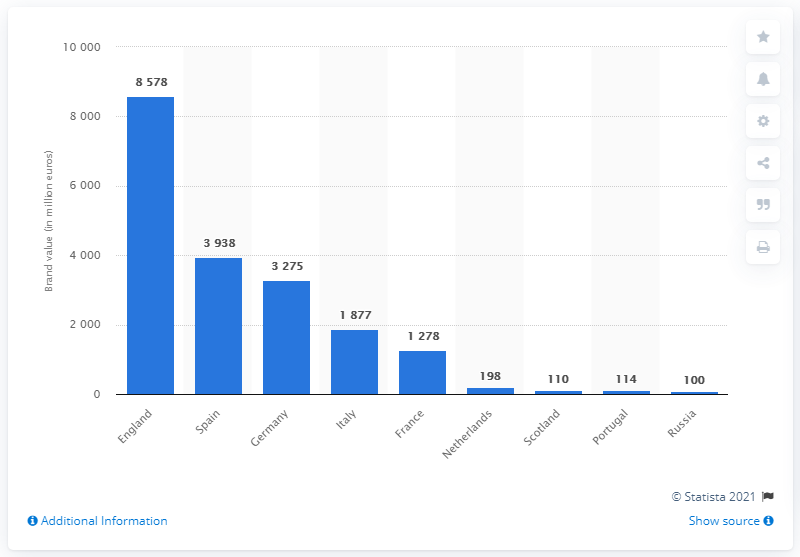Identify some key points in this picture. Out of the countries, only 4 have less than 200 million euros. The brand value of the Premier League in 2020 was estimated to be 8,578. The Netherlands has a brand value of 198 million euros, making it the country with the highest brand value in terms of million euros. 